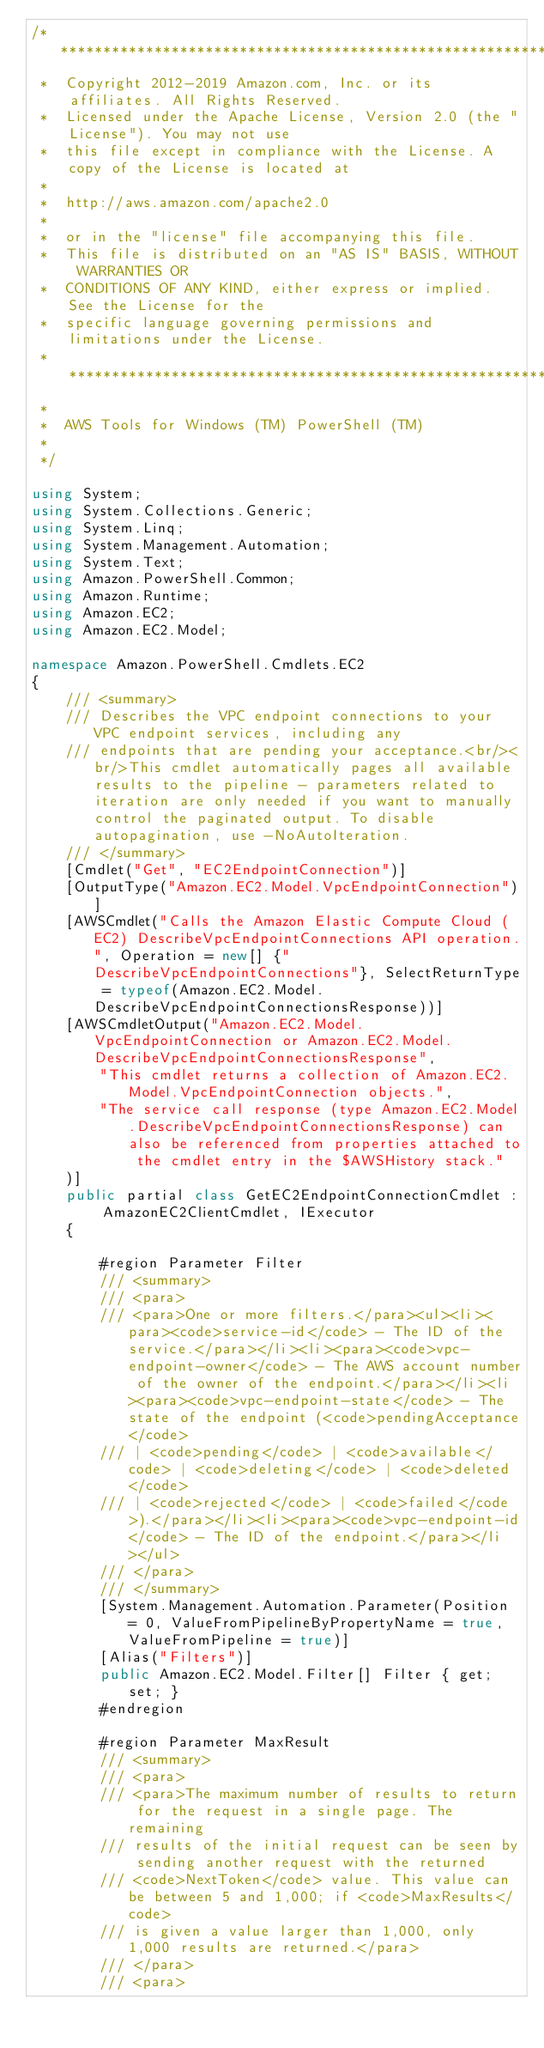<code> <loc_0><loc_0><loc_500><loc_500><_C#_>/*******************************************************************************
 *  Copyright 2012-2019 Amazon.com, Inc. or its affiliates. All Rights Reserved.
 *  Licensed under the Apache License, Version 2.0 (the "License"). You may not use
 *  this file except in compliance with the License. A copy of the License is located at
 *
 *  http://aws.amazon.com/apache2.0
 *
 *  or in the "license" file accompanying this file.
 *  This file is distributed on an "AS IS" BASIS, WITHOUT WARRANTIES OR
 *  CONDITIONS OF ANY KIND, either express or implied. See the License for the
 *  specific language governing permissions and limitations under the License.
 * *****************************************************************************
 *
 *  AWS Tools for Windows (TM) PowerShell (TM)
 *
 */

using System;
using System.Collections.Generic;
using System.Linq;
using System.Management.Automation;
using System.Text;
using Amazon.PowerShell.Common;
using Amazon.Runtime;
using Amazon.EC2;
using Amazon.EC2.Model;

namespace Amazon.PowerShell.Cmdlets.EC2
{
    /// <summary>
    /// Describes the VPC endpoint connections to your VPC endpoint services, including any
    /// endpoints that are pending your acceptance.<br/><br/>This cmdlet automatically pages all available results to the pipeline - parameters related to iteration are only needed if you want to manually control the paginated output. To disable autopagination, use -NoAutoIteration.
    /// </summary>
    [Cmdlet("Get", "EC2EndpointConnection")]
    [OutputType("Amazon.EC2.Model.VpcEndpointConnection")]
    [AWSCmdlet("Calls the Amazon Elastic Compute Cloud (EC2) DescribeVpcEndpointConnections API operation.", Operation = new[] {"DescribeVpcEndpointConnections"}, SelectReturnType = typeof(Amazon.EC2.Model.DescribeVpcEndpointConnectionsResponse))]
    [AWSCmdletOutput("Amazon.EC2.Model.VpcEndpointConnection or Amazon.EC2.Model.DescribeVpcEndpointConnectionsResponse",
        "This cmdlet returns a collection of Amazon.EC2.Model.VpcEndpointConnection objects.",
        "The service call response (type Amazon.EC2.Model.DescribeVpcEndpointConnectionsResponse) can also be referenced from properties attached to the cmdlet entry in the $AWSHistory stack."
    )]
    public partial class GetEC2EndpointConnectionCmdlet : AmazonEC2ClientCmdlet, IExecutor
    {
        
        #region Parameter Filter
        /// <summary>
        /// <para>
        /// <para>One or more filters.</para><ul><li><para><code>service-id</code> - The ID of the service.</para></li><li><para><code>vpc-endpoint-owner</code> - The AWS account number of the owner of the endpoint.</para></li><li><para><code>vpc-endpoint-state</code> - The state of the endpoint (<code>pendingAcceptance</code>
        /// | <code>pending</code> | <code>available</code> | <code>deleting</code> | <code>deleted</code>
        /// | <code>rejected</code> | <code>failed</code>).</para></li><li><para><code>vpc-endpoint-id</code> - The ID of the endpoint.</para></li></ul>
        /// </para>
        /// </summary>
        [System.Management.Automation.Parameter(Position = 0, ValueFromPipelineByPropertyName = true, ValueFromPipeline = true)]
        [Alias("Filters")]
        public Amazon.EC2.Model.Filter[] Filter { get; set; }
        #endregion
        
        #region Parameter MaxResult
        /// <summary>
        /// <para>
        /// <para>The maximum number of results to return for the request in a single page. The remaining
        /// results of the initial request can be seen by sending another request with the returned
        /// <code>NextToken</code> value. This value can be between 5 and 1,000; if <code>MaxResults</code>
        /// is given a value larger than 1,000, only 1,000 results are returned.</para>
        /// </para>
        /// <para></code> 